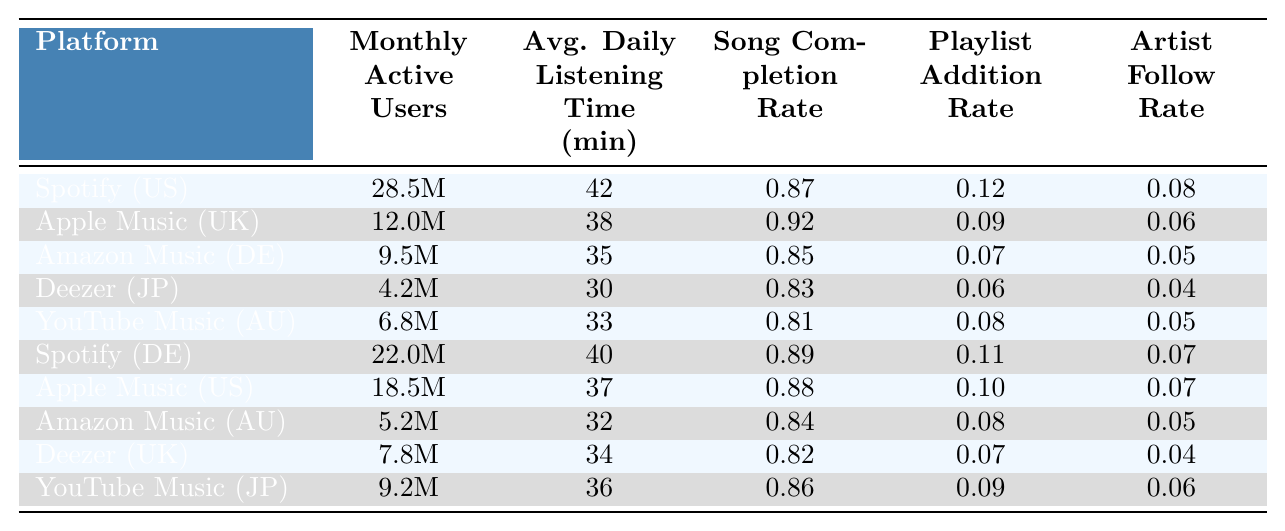What is the Monthly Active Users count for Spotify in the United States? From the table, the Monthly Active Users (MAU) for Spotify specific to the United States is clearly listed as 28.5 million.
Answer: 28.5 million Which platform has the highest Average Daily Listening Time for Classic Rock in Germany? In the table, Spotify represents the Classic Rock subgenre in Germany with an average daily listening time of 40 minutes, which is higher than any other platform shown for that subgenre in that country.
Answer: Spotify What is the Song Completion Rate for YouTube Music in Japan? The Song Completion Rate for YouTube Music in Japan can be found directly in the table, which lists it as 0.86.
Answer: 0.86 Which country has the highest number of Monthly Active Users for Apple Music? To find the highest number of Monthly Active Users for Apple Music, we look at the table entries for Apple Music, which are in the United Kingdom and the United States. The United States has 18.5 million MAU, while the United Kingdom has 12 million, making the United States the highest.
Answer: United States How many more Monthly Active Users does Spotify have in the United States compared to Amazon Music in Germany? From the table, Spotify has 28.5 million MAU in the United States and Amazon Music has 9.5 million MAU in Germany. The difference is 28.5 million - 9.5 million = 19 million.
Answer: 19 million Is the Artist Follow Rate for Deezer in the United Kingdom higher than 0.05? The table shows that the Artist Follow Rate for Deezer in the United Kingdom is 0.04, which is lower than 0.05, making the statement false.
Answer: No What is the average Average Daily Listening Time for Punk Rock across all platforms? The Average Daily Listening Times for Punk Rock are listed as follows: 33 (YouTube Music in Australia) and 34 (Deezer in the United Kingdom). The average is (33 + 34) / 2 = 33.5 minutes.
Answer: 33.5 minutes Which platform has the lowest Playlist Addition Rate across all countries? The table shows that Deezer in Japan has the lowest Playlist Addition Rate at 0.06 when comparing all entries across platforms and countries.
Answer: Deezer in Japan How does the Monthly Active Users count of Amazon Music in Germany compare to that of Spotify in Germany? For Amazon Music in Germany, the Monthly Active Users count is 9.5 million, while for Spotify in Germany, it is 22 million. Comparing these values, Spotify has more users. The difference is 22 million - 9.5 million = 12.5 million.
Answer: Spotify has 12.5 million more What percentage of listeners in the United States on Apple Music add songs to playlists based on the Playlist Addition Rate? The Playlist Addition Rate for Apple Music in the United States is 0.10. To express this as a percentage, you multiply by 100, giving you 10%.
Answer: 10% 